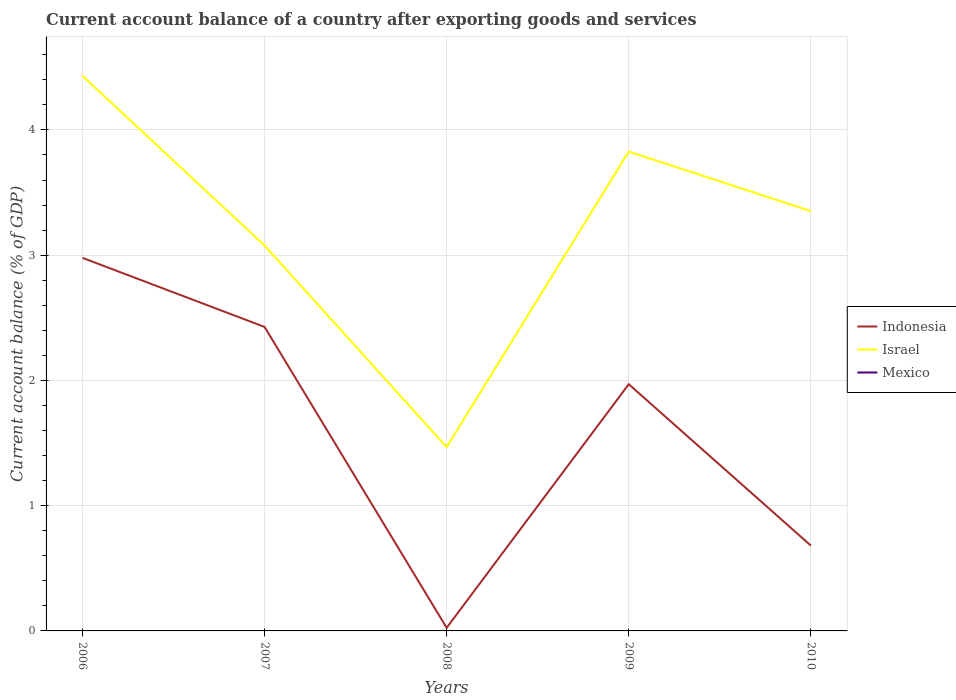Does the line corresponding to Israel intersect with the line corresponding to Mexico?
Your response must be concise. No. Across all years, what is the maximum account balance in Israel?
Ensure brevity in your answer.  1.47. What is the total account balance in Indonesia in the graph?
Ensure brevity in your answer.  2.3. What is the difference between the highest and the second highest account balance in Indonesia?
Provide a succinct answer. 2.95. Is the account balance in Indonesia strictly greater than the account balance in Israel over the years?
Provide a succinct answer. Yes. How many lines are there?
Ensure brevity in your answer.  2. What is the difference between two consecutive major ticks on the Y-axis?
Give a very brief answer. 1. How many legend labels are there?
Offer a terse response. 3. How are the legend labels stacked?
Your answer should be very brief. Vertical. What is the title of the graph?
Provide a succinct answer. Current account balance of a country after exporting goods and services. Does "Cameroon" appear as one of the legend labels in the graph?
Give a very brief answer. No. What is the label or title of the Y-axis?
Offer a very short reply. Current account balance (% of GDP). What is the Current account balance (% of GDP) in Indonesia in 2006?
Your response must be concise. 2.98. What is the Current account balance (% of GDP) in Israel in 2006?
Your answer should be very brief. 4.43. What is the Current account balance (% of GDP) in Mexico in 2006?
Keep it short and to the point. 0. What is the Current account balance (% of GDP) of Indonesia in 2007?
Offer a very short reply. 2.43. What is the Current account balance (% of GDP) of Israel in 2007?
Ensure brevity in your answer.  3.08. What is the Current account balance (% of GDP) of Indonesia in 2008?
Give a very brief answer. 0.02. What is the Current account balance (% of GDP) in Israel in 2008?
Your answer should be compact. 1.47. What is the Current account balance (% of GDP) in Indonesia in 2009?
Your response must be concise. 1.97. What is the Current account balance (% of GDP) in Israel in 2009?
Ensure brevity in your answer.  3.83. What is the Current account balance (% of GDP) of Indonesia in 2010?
Make the answer very short. 0.68. What is the Current account balance (% of GDP) in Israel in 2010?
Your answer should be compact. 3.35. What is the Current account balance (% of GDP) in Mexico in 2010?
Provide a short and direct response. 0. Across all years, what is the maximum Current account balance (% of GDP) of Indonesia?
Provide a succinct answer. 2.98. Across all years, what is the maximum Current account balance (% of GDP) of Israel?
Offer a very short reply. 4.43. Across all years, what is the minimum Current account balance (% of GDP) in Indonesia?
Your answer should be very brief. 0.02. Across all years, what is the minimum Current account balance (% of GDP) in Israel?
Make the answer very short. 1.47. What is the total Current account balance (% of GDP) of Indonesia in the graph?
Provide a succinct answer. 8.08. What is the total Current account balance (% of GDP) of Israel in the graph?
Offer a very short reply. 16.16. What is the total Current account balance (% of GDP) in Mexico in the graph?
Offer a terse response. 0. What is the difference between the Current account balance (% of GDP) in Indonesia in 2006 and that in 2007?
Keep it short and to the point. 0.55. What is the difference between the Current account balance (% of GDP) in Israel in 2006 and that in 2007?
Provide a short and direct response. 1.35. What is the difference between the Current account balance (% of GDP) in Indonesia in 2006 and that in 2008?
Give a very brief answer. 2.95. What is the difference between the Current account balance (% of GDP) of Israel in 2006 and that in 2008?
Give a very brief answer. 2.96. What is the difference between the Current account balance (% of GDP) of Indonesia in 2006 and that in 2009?
Ensure brevity in your answer.  1.01. What is the difference between the Current account balance (% of GDP) in Israel in 2006 and that in 2009?
Your answer should be very brief. 0.61. What is the difference between the Current account balance (% of GDP) in Indonesia in 2006 and that in 2010?
Give a very brief answer. 2.3. What is the difference between the Current account balance (% of GDP) of Israel in 2006 and that in 2010?
Offer a terse response. 1.08. What is the difference between the Current account balance (% of GDP) in Indonesia in 2007 and that in 2008?
Your answer should be compact. 2.4. What is the difference between the Current account balance (% of GDP) of Israel in 2007 and that in 2008?
Provide a succinct answer. 1.61. What is the difference between the Current account balance (% of GDP) of Indonesia in 2007 and that in 2009?
Provide a short and direct response. 0.46. What is the difference between the Current account balance (% of GDP) in Israel in 2007 and that in 2009?
Keep it short and to the point. -0.75. What is the difference between the Current account balance (% of GDP) of Indonesia in 2007 and that in 2010?
Provide a succinct answer. 1.75. What is the difference between the Current account balance (% of GDP) of Israel in 2007 and that in 2010?
Offer a terse response. -0.27. What is the difference between the Current account balance (% of GDP) in Indonesia in 2008 and that in 2009?
Your answer should be compact. -1.95. What is the difference between the Current account balance (% of GDP) in Israel in 2008 and that in 2009?
Offer a terse response. -2.36. What is the difference between the Current account balance (% of GDP) of Indonesia in 2008 and that in 2010?
Offer a terse response. -0.66. What is the difference between the Current account balance (% of GDP) of Israel in 2008 and that in 2010?
Your answer should be compact. -1.88. What is the difference between the Current account balance (% of GDP) in Indonesia in 2009 and that in 2010?
Your answer should be compact. 1.29. What is the difference between the Current account balance (% of GDP) of Israel in 2009 and that in 2010?
Your answer should be very brief. 0.48. What is the difference between the Current account balance (% of GDP) in Indonesia in 2006 and the Current account balance (% of GDP) in Israel in 2007?
Make the answer very short. -0.1. What is the difference between the Current account balance (% of GDP) of Indonesia in 2006 and the Current account balance (% of GDP) of Israel in 2008?
Keep it short and to the point. 1.51. What is the difference between the Current account balance (% of GDP) in Indonesia in 2006 and the Current account balance (% of GDP) in Israel in 2009?
Keep it short and to the point. -0.85. What is the difference between the Current account balance (% of GDP) in Indonesia in 2006 and the Current account balance (% of GDP) in Israel in 2010?
Ensure brevity in your answer.  -0.37. What is the difference between the Current account balance (% of GDP) in Indonesia in 2007 and the Current account balance (% of GDP) in Israel in 2008?
Provide a succinct answer. 0.96. What is the difference between the Current account balance (% of GDP) in Indonesia in 2007 and the Current account balance (% of GDP) in Israel in 2009?
Keep it short and to the point. -1.4. What is the difference between the Current account balance (% of GDP) in Indonesia in 2007 and the Current account balance (% of GDP) in Israel in 2010?
Offer a terse response. -0.92. What is the difference between the Current account balance (% of GDP) in Indonesia in 2008 and the Current account balance (% of GDP) in Israel in 2009?
Make the answer very short. -3.8. What is the difference between the Current account balance (% of GDP) of Indonesia in 2008 and the Current account balance (% of GDP) of Israel in 2010?
Give a very brief answer. -3.33. What is the difference between the Current account balance (% of GDP) of Indonesia in 2009 and the Current account balance (% of GDP) of Israel in 2010?
Ensure brevity in your answer.  -1.38. What is the average Current account balance (% of GDP) of Indonesia per year?
Provide a succinct answer. 1.62. What is the average Current account balance (% of GDP) in Israel per year?
Give a very brief answer. 3.23. In the year 2006, what is the difference between the Current account balance (% of GDP) in Indonesia and Current account balance (% of GDP) in Israel?
Keep it short and to the point. -1.45. In the year 2007, what is the difference between the Current account balance (% of GDP) of Indonesia and Current account balance (% of GDP) of Israel?
Offer a very short reply. -0.65. In the year 2008, what is the difference between the Current account balance (% of GDP) of Indonesia and Current account balance (% of GDP) of Israel?
Provide a succinct answer. -1.44. In the year 2009, what is the difference between the Current account balance (% of GDP) of Indonesia and Current account balance (% of GDP) of Israel?
Your response must be concise. -1.86. In the year 2010, what is the difference between the Current account balance (% of GDP) in Indonesia and Current account balance (% of GDP) in Israel?
Give a very brief answer. -2.67. What is the ratio of the Current account balance (% of GDP) in Indonesia in 2006 to that in 2007?
Provide a succinct answer. 1.23. What is the ratio of the Current account balance (% of GDP) in Israel in 2006 to that in 2007?
Your answer should be compact. 1.44. What is the ratio of the Current account balance (% of GDP) of Indonesia in 2006 to that in 2008?
Provide a short and direct response. 120.63. What is the ratio of the Current account balance (% of GDP) of Israel in 2006 to that in 2008?
Your response must be concise. 3.02. What is the ratio of the Current account balance (% of GDP) of Indonesia in 2006 to that in 2009?
Give a very brief answer. 1.51. What is the ratio of the Current account balance (% of GDP) of Israel in 2006 to that in 2009?
Provide a short and direct response. 1.16. What is the ratio of the Current account balance (% of GDP) of Indonesia in 2006 to that in 2010?
Your answer should be very brief. 4.37. What is the ratio of the Current account balance (% of GDP) of Israel in 2006 to that in 2010?
Give a very brief answer. 1.32. What is the ratio of the Current account balance (% of GDP) of Indonesia in 2007 to that in 2008?
Make the answer very short. 98.3. What is the ratio of the Current account balance (% of GDP) in Israel in 2007 to that in 2008?
Give a very brief answer. 2.1. What is the ratio of the Current account balance (% of GDP) in Indonesia in 2007 to that in 2009?
Your response must be concise. 1.23. What is the ratio of the Current account balance (% of GDP) of Israel in 2007 to that in 2009?
Offer a very short reply. 0.8. What is the ratio of the Current account balance (% of GDP) of Indonesia in 2007 to that in 2010?
Make the answer very short. 3.56. What is the ratio of the Current account balance (% of GDP) of Israel in 2007 to that in 2010?
Provide a succinct answer. 0.92. What is the ratio of the Current account balance (% of GDP) in Indonesia in 2008 to that in 2009?
Provide a short and direct response. 0.01. What is the ratio of the Current account balance (% of GDP) in Israel in 2008 to that in 2009?
Keep it short and to the point. 0.38. What is the ratio of the Current account balance (% of GDP) of Indonesia in 2008 to that in 2010?
Give a very brief answer. 0.04. What is the ratio of the Current account balance (% of GDP) of Israel in 2008 to that in 2010?
Keep it short and to the point. 0.44. What is the ratio of the Current account balance (% of GDP) of Indonesia in 2009 to that in 2010?
Offer a very short reply. 2.89. What is the ratio of the Current account balance (% of GDP) in Israel in 2009 to that in 2010?
Provide a succinct answer. 1.14. What is the difference between the highest and the second highest Current account balance (% of GDP) of Indonesia?
Make the answer very short. 0.55. What is the difference between the highest and the second highest Current account balance (% of GDP) in Israel?
Make the answer very short. 0.61. What is the difference between the highest and the lowest Current account balance (% of GDP) of Indonesia?
Your answer should be very brief. 2.95. What is the difference between the highest and the lowest Current account balance (% of GDP) of Israel?
Your answer should be compact. 2.96. 